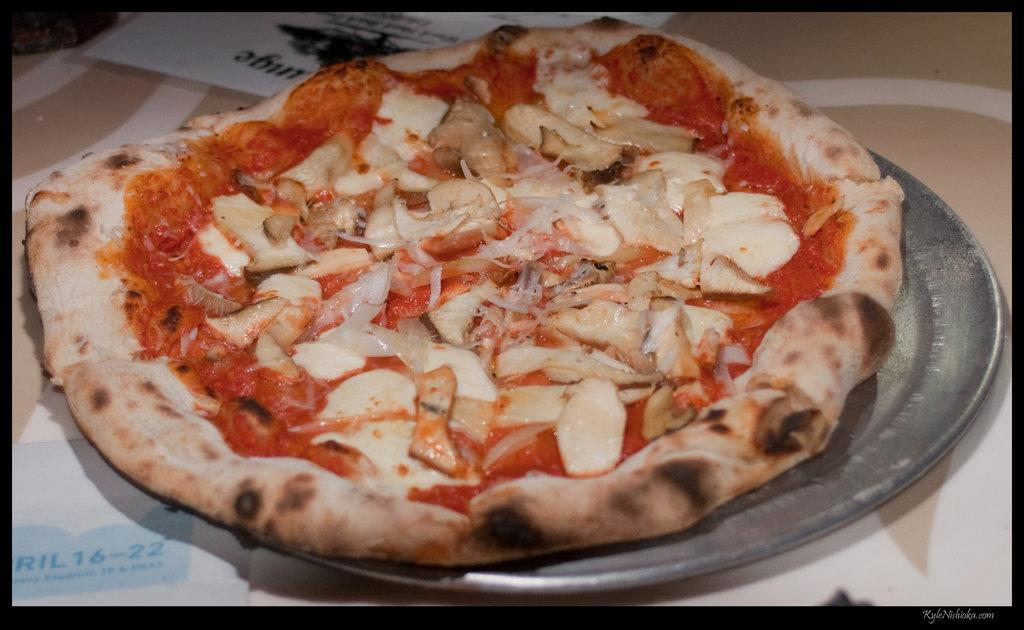What type of food is the main subject of the image? There is a pizza in the image. What can be found inside the pizza? The pizza has stuffings. How is the pizza presented in the image? The pizza is placed on a plate. Where is the plate with the pizza located? The plate is on a table. What type of partner is the pizza looking for in the image? The pizza is not a living being and therefore cannot have a partner or seek one. 